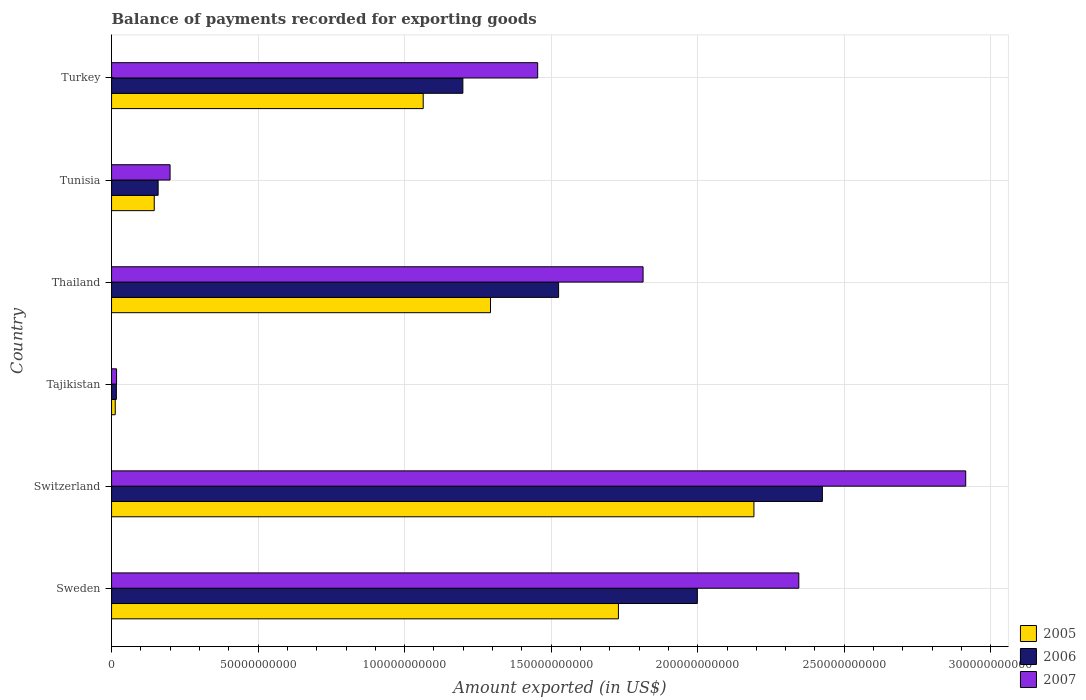How many different coloured bars are there?
Your response must be concise. 3. How many groups of bars are there?
Your answer should be compact. 6. Are the number of bars per tick equal to the number of legend labels?
Keep it short and to the point. Yes. What is the label of the 1st group of bars from the top?
Provide a succinct answer. Turkey. What is the amount exported in 2005 in Tajikistan?
Your response must be concise. 1.25e+09. Across all countries, what is the maximum amount exported in 2006?
Provide a short and direct response. 2.43e+11. Across all countries, what is the minimum amount exported in 2007?
Provide a succinct answer. 1.71e+09. In which country was the amount exported in 2005 maximum?
Your response must be concise. Switzerland. In which country was the amount exported in 2007 minimum?
Your answer should be very brief. Tajikistan. What is the total amount exported in 2007 in the graph?
Give a very brief answer. 8.74e+11. What is the difference between the amount exported in 2006 in Sweden and that in Tunisia?
Provide a short and direct response. 1.84e+11. What is the difference between the amount exported in 2006 in Tunisia and the amount exported in 2007 in Switzerland?
Provide a succinct answer. -2.76e+11. What is the average amount exported in 2005 per country?
Provide a succinct answer. 1.07e+11. What is the difference between the amount exported in 2005 and amount exported in 2006 in Turkey?
Provide a succinct answer. -1.35e+1. In how many countries, is the amount exported in 2005 greater than 210000000000 US$?
Ensure brevity in your answer.  1. What is the ratio of the amount exported in 2006 in Switzerland to that in Tajikistan?
Give a very brief answer. 147.34. Is the difference between the amount exported in 2005 in Tajikistan and Thailand greater than the difference between the amount exported in 2006 in Tajikistan and Thailand?
Give a very brief answer. Yes. What is the difference between the highest and the second highest amount exported in 2005?
Give a very brief answer. 4.62e+1. What is the difference between the highest and the lowest amount exported in 2007?
Keep it short and to the point. 2.90e+11. In how many countries, is the amount exported in 2006 greater than the average amount exported in 2006 taken over all countries?
Keep it short and to the point. 3. Is the sum of the amount exported in 2007 in Switzerland and Tajikistan greater than the maximum amount exported in 2006 across all countries?
Offer a terse response. Yes. What does the 1st bar from the top in Tunisia represents?
Make the answer very short. 2007. How many bars are there?
Your answer should be compact. 18. Are all the bars in the graph horizontal?
Ensure brevity in your answer.  Yes. How many countries are there in the graph?
Your response must be concise. 6. What is the difference between two consecutive major ticks on the X-axis?
Your answer should be very brief. 5.00e+1. What is the title of the graph?
Your response must be concise. Balance of payments recorded for exporting goods. What is the label or title of the X-axis?
Provide a succinct answer. Amount exported (in US$). What is the Amount exported (in US$) of 2005 in Sweden?
Your response must be concise. 1.73e+11. What is the Amount exported (in US$) in 2006 in Sweden?
Keep it short and to the point. 2.00e+11. What is the Amount exported (in US$) of 2007 in Sweden?
Give a very brief answer. 2.34e+11. What is the Amount exported (in US$) in 2005 in Switzerland?
Give a very brief answer. 2.19e+11. What is the Amount exported (in US$) of 2006 in Switzerland?
Provide a succinct answer. 2.43e+11. What is the Amount exported (in US$) in 2007 in Switzerland?
Give a very brief answer. 2.91e+11. What is the Amount exported (in US$) of 2005 in Tajikistan?
Offer a very short reply. 1.25e+09. What is the Amount exported (in US$) in 2006 in Tajikistan?
Give a very brief answer. 1.65e+09. What is the Amount exported (in US$) of 2007 in Tajikistan?
Offer a very short reply. 1.71e+09. What is the Amount exported (in US$) in 2005 in Thailand?
Your answer should be compact. 1.29e+11. What is the Amount exported (in US$) in 2006 in Thailand?
Give a very brief answer. 1.53e+11. What is the Amount exported (in US$) of 2007 in Thailand?
Provide a succinct answer. 1.81e+11. What is the Amount exported (in US$) in 2005 in Tunisia?
Make the answer very short. 1.46e+1. What is the Amount exported (in US$) of 2006 in Tunisia?
Keep it short and to the point. 1.59e+1. What is the Amount exported (in US$) of 2007 in Tunisia?
Ensure brevity in your answer.  2.00e+1. What is the Amount exported (in US$) of 2005 in Turkey?
Give a very brief answer. 1.06e+11. What is the Amount exported (in US$) of 2006 in Turkey?
Your answer should be very brief. 1.20e+11. What is the Amount exported (in US$) of 2007 in Turkey?
Keep it short and to the point. 1.45e+11. Across all countries, what is the maximum Amount exported (in US$) in 2005?
Your answer should be very brief. 2.19e+11. Across all countries, what is the maximum Amount exported (in US$) of 2006?
Make the answer very short. 2.43e+11. Across all countries, what is the maximum Amount exported (in US$) in 2007?
Your response must be concise. 2.91e+11. Across all countries, what is the minimum Amount exported (in US$) of 2005?
Your answer should be compact. 1.25e+09. Across all countries, what is the minimum Amount exported (in US$) of 2006?
Your response must be concise. 1.65e+09. Across all countries, what is the minimum Amount exported (in US$) of 2007?
Keep it short and to the point. 1.71e+09. What is the total Amount exported (in US$) in 2005 in the graph?
Your answer should be compact. 6.44e+11. What is the total Amount exported (in US$) of 2006 in the graph?
Your answer should be compact. 7.32e+11. What is the total Amount exported (in US$) in 2007 in the graph?
Your response must be concise. 8.74e+11. What is the difference between the Amount exported (in US$) in 2005 in Sweden and that in Switzerland?
Your response must be concise. -4.62e+1. What is the difference between the Amount exported (in US$) of 2006 in Sweden and that in Switzerland?
Make the answer very short. -4.27e+1. What is the difference between the Amount exported (in US$) in 2007 in Sweden and that in Switzerland?
Your answer should be very brief. -5.69e+1. What is the difference between the Amount exported (in US$) of 2005 in Sweden and that in Tajikistan?
Provide a short and direct response. 1.72e+11. What is the difference between the Amount exported (in US$) of 2006 in Sweden and that in Tajikistan?
Your response must be concise. 1.98e+11. What is the difference between the Amount exported (in US$) in 2007 in Sweden and that in Tajikistan?
Provide a short and direct response. 2.33e+11. What is the difference between the Amount exported (in US$) in 2005 in Sweden and that in Thailand?
Provide a short and direct response. 4.36e+1. What is the difference between the Amount exported (in US$) of 2006 in Sweden and that in Thailand?
Your answer should be compact. 4.73e+1. What is the difference between the Amount exported (in US$) in 2007 in Sweden and that in Thailand?
Offer a terse response. 5.31e+1. What is the difference between the Amount exported (in US$) of 2005 in Sweden and that in Tunisia?
Give a very brief answer. 1.58e+11. What is the difference between the Amount exported (in US$) in 2006 in Sweden and that in Tunisia?
Give a very brief answer. 1.84e+11. What is the difference between the Amount exported (in US$) in 2007 in Sweden and that in Tunisia?
Offer a terse response. 2.15e+11. What is the difference between the Amount exported (in US$) in 2005 in Sweden and that in Turkey?
Provide a succinct answer. 6.66e+1. What is the difference between the Amount exported (in US$) in 2006 in Sweden and that in Turkey?
Ensure brevity in your answer.  8.00e+1. What is the difference between the Amount exported (in US$) in 2007 in Sweden and that in Turkey?
Offer a terse response. 8.91e+1. What is the difference between the Amount exported (in US$) of 2005 in Switzerland and that in Tajikistan?
Ensure brevity in your answer.  2.18e+11. What is the difference between the Amount exported (in US$) of 2006 in Switzerland and that in Tajikistan?
Your answer should be very brief. 2.41e+11. What is the difference between the Amount exported (in US$) in 2007 in Switzerland and that in Tajikistan?
Provide a succinct answer. 2.90e+11. What is the difference between the Amount exported (in US$) in 2005 in Switzerland and that in Thailand?
Offer a very short reply. 8.99e+1. What is the difference between the Amount exported (in US$) of 2006 in Switzerland and that in Thailand?
Your answer should be compact. 9.00e+1. What is the difference between the Amount exported (in US$) in 2007 in Switzerland and that in Thailand?
Your answer should be very brief. 1.10e+11. What is the difference between the Amount exported (in US$) in 2005 in Switzerland and that in Tunisia?
Your answer should be compact. 2.05e+11. What is the difference between the Amount exported (in US$) of 2006 in Switzerland and that in Tunisia?
Your answer should be very brief. 2.27e+11. What is the difference between the Amount exported (in US$) of 2007 in Switzerland and that in Tunisia?
Your answer should be compact. 2.71e+11. What is the difference between the Amount exported (in US$) of 2005 in Switzerland and that in Turkey?
Give a very brief answer. 1.13e+11. What is the difference between the Amount exported (in US$) in 2006 in Switzerland and that in Turkey?
Give a very brief answer. 1.23e+11. What is the difference between the Amount exported (in US$) of 2007 in Switzerland and that in Turkey?
Give a very brief answer. 1.46e+11. What is the difference between the Amount exported (in US$) in 2005 in Tajikistan and that in Thailand?
Your answer should be compact. -1.28e+11. What is the difference between the Amount exported (in US$) in 2006 in Tajikistan and that in Thailand?
Offer a very short reply. -1.51e+11. What is the difference between the Amount exported (in US$) in 2007 in Tajikistan and that in Thailand?
Your response must be concise. -1.80e+11. What is the difference between the Amount exported (in US$) in 2005 in Tajikistan and that in Tunisia?
Your answer should be very brief. -1.33e+1. What is the difference between the Amount exported (in US$) in 2006 in Tajikistan and that in Tunisia?
Give a very brief answer. -1.42e+1. What is the difference between the Amount exported (in US$) in 2007 in Tajikistan and that in Tunisia?
Your answer should be very brief. -1.83e+1. What is the difference between the Amount exported (in US$) of 2005 in Tajikistan and that in Turkey?
Give a very brief answer. -1.05e+11. What is the difference between the Amount exported (in US$) of 2006 in Tajikistan and that in Turkey?
Provide a short and direct response. -1.18e+11. What is the difference between the Amount exported (in US$) in 2007 in Tajikistan and that in Turkey?
Offer a very short reply. -1.44e+11. What is the difference between the Amount exported (in US$) in 2005 in Thailand and that in Tunisia?
Your answer should be very brief. 1.15e+11. What is the difference between the Amount exported (in US$) in 2006 in Thailand and that in Tunisia?
Keep it short and to the point. 1.37e+11. What is the difference between the Amount exported (in US$) of 2007 in Thailand and that in Tunisia?
Make the answer very short. 1.61e+11. What is the difference between the Amount exported (in US$) in 2005 in Thailand and that in Turkey?
Your response must be concise. 2.30e+1. What is the difference between the Amount exported (in US$) in 2006 in Thailand and that in Turkey?
Provide a short and direct response. 3.27e+1. What is the difference between the Amount exported (in US$) in 2007 in Thailand and that in Turkey?
Your answer should be compact. 3.60e+1. What is the difference between the Amount exported (in US$) in 2005 in Tunisia and that in Turkey?
Your answer should be compact. -9.18e+1. What is the difference between the Amount exported (in US$) in 2006 in Tunisia and that in Turkey?
Your answer should be compact. -1.04e+11. What is the difference between the Amount exported (in US$) in 2007 in Tunisia and that in Turkey?
Ensure brevity in your answer.  -1.25e+11. What is the difference between the Amount exported (in US$) in 2005 in Sweden and the Amount exported (in US$) in 2006 in Switzerland?
Your answer should be compact. -6.96e+1. What is the difference between the Amount exported (in US$) of 2005 in Sweden and the Amount exported (in US$) of 2007 in Switzerland?
Provide a short and direct response. -1.18e+11. What is the difference between the Amount exported (in US$) in 2006 in Sweden and the Amount exported (in US$) in 2007 in Switzerland?
Offer a terse response. -9.16e+1. What is the difference between the Amount exported (in US$) of 2005 in Sweden and the Amount exported (in US$) of 2006 in Tajikistan?
Provide a succinct answer. 1.71e+11. What is the difference between the Amount exported (in US$) of 2005 in Sweden and the Amount exported (in US$) of 2007 in Tajikistan?
Your answer should be compact. 1.71e+11. What is the difference between the Amount exported (in US$) of 2006 in Sweden and the Amount exported (in US$) of 2007 in Tajikistan?
Keep it short and to the point. 1.98e+11. What is the difference between the Amount exported (in US$) in 2005 in Sweden and the Amount exported (in US$) in 2006 in Thailand?
Ensure brevity in your answer.  2.04e+1. What is the difference between the Amount exported (in US$) of 2005 in Sweden and the Amount exported (in US$) of 2007 in Thailand?
Provide a short and direct response. -8.41e+09. What is the difference between the Amount exported (in US$) of 2006 in Sweden and the Amount exported (in US$) of 2007 in Thailand?
Your response must be concise. 1.85e+1. What is the difference between the Amount exported (in US$) of 2005 in Sweden and the Amount exported (in US$) of 2006 in Tunisia?
Offer a very short reply. 1.57e+11. What is the difference between the Amount exported (in US$) of 2005 in Sweden and the Amount exported (in US$) of 2007 in Tunisia?
Offer a very short reply. 1.53e+11. What is the difference between the Amount exported (in US$) in 2006 in Sweden and the Amount exported (in US$) in 2007 in Tunisia?
Offer a terse response. 1.80e+11. What is the difference between the Amount exported (in US$) of 2005 in Sweden and the Amount exported (in US$) of 2006 in Turkey?
Give a very brief answer. 5.31e+1. What is the difference between the Amount exported (in US$) of 2005 in Sweden and the Amount exported (in US$) of 2007 in Turkey?
Make the answer very short. 2.76e+1. What is the difference between the Amount exported (in US$) in 2006 in Sweden and the Amount exported (in US$) in 2007 in Turkey?
Offer a terse response. 5.45e+1. What is the difference between the Amount exported (in US$) of 2005 in Switzerland and the Amount exported (in US$) of 2006 in Tajikistan?
Keep it short and to the point. 2.18e+11. What is the difference between the Amount exported (in US$) of 2005 in Switzerland and the Amount exported (in US$) of 2007 in Tajikistan?
Make the answer very short. 2.17e+11. What is the difference between the Amount exported (in US$) of 2006 in Switzerland and the Amount exported (in US$) of 2007 in Tajikistan?
Offer a very short reply. 2.41e+11. What is the difference between the Amount exported (in US$) in 2005 in Switzerland and the Amount exported (in US$) in 2006 in Thailand?
Provide a short and direct response. 6.66e+1. What is the difference between the Amount exported (in US$) in 2005 in Switzerland and the Amount exported (in US$) in 2007 in Thailand?
Ensure brevity in your answer.  3.78e+1. What is the difference between the Amount exported (in US$) in 2006 in Switzerland and the Amount exported (in US$) in 2007 in Thailand?
Make the answer very short. 6.12e+1. What is the difference between the Amount exported (in US$) of 2005 in Switzerland and the Amount exported (in US$) of 2006 in Tunisia?
Make the answer very short. 2.03e+11. What is the difference between the Amount exported (in US$) in 2005 in Switzerland and the Amount exported (in US$) in 2007 in Tunisia?
Ensure brevity in your answer.  1.99e+11. What is the difference between the Amount exported (in US$) in 2006 in Switzerland and the Amount exported (in US$) in 2007 in Tunisia?
Offer a terse response. 2.23e+11. What is the difference between the Amount exported (in US$) in 2005 in Switzerland and the Amount exported (in US$) in 2006 in Turkey?
Make the answer very short. 9.93e+1. What is the difference between the Amount exported (in US$) in 2005 in Switzerland and the Amount exported (in US$) in 2007 in Turkey?
Provide a succinct answer. 7.38e+1. What is the difference between the Amount exported (in US$) of 2006 in Switzerland and the Amount exported (in US$) of 2007 in Turkey?
Make the answer very short. 9.71e+1. What is the difference between the Amount exported (in US$) of 2005 in Tajikistan and the Amount exported (in US$) of 2006 in Thailand?
Give a very brief answer. -1.51e+11. What is the difference between the Amount exported (in US$) in 2005 in Tajikistan and the Amount exported (in US$) in 2007 in Thailand?
Provide a succinct answer. -1.80e+11. What is the difference between the Amount exported (in US$) in 2006 in Tajikistan and the Amount exported (in US$) in 2007 in Thailand?
Provide a short and direct response. -1.80e+11. What is the difference between the Amount exported (in US$) of 2005 in Tajikistan and the Amount exported (in US$) of 2006 in Tunisia?
Provide a succinct answer. -1.46e+1. What is the difference between the Amount exported (in US$) in 2005 in Tajikistan and the Amount exported (in US$) in 2007 in Tunisia?
Keep it short and to the point. -1.87e+1. What is the difference between the Amount exported (in US$) in 2006 in Tajikistan and the Amount exported (in US$) in 2007 in Tunisia?
Offer a very short reply. -1.83e+1. What is the difference between the Amount exported (in US$) in 2005 in Tajikistan and the Amount exported (in US$) in 2006 in Turkey?
Your response must be concise. -1.19e+11. What is the difference between the Amount exported (in US$) in 2005 in Tajikistan and the Amount exported (in US$) in 2007 in Turkey?
Your answer should be compact. -1.44e+11. What is the difference between the Amount exported (in US$) in 2006 in Tajikistan and the Amount exported (in US$) in 2007 in Turkey?
Your answer should be very brief. -1.44e+11. What is the difference between the Amount exported (in US$) of 2005 in Thailand and the Amount exported (in US$) of 2006 in Tunisia?
Offer a terse response. 1.13e+11. What is the difference between the Amount exported (in US$) of 2005 in Thailand and the Amount exported (in US$) of 2007 in Tunisia?
Your answer should be compact. 1.09e+11. What is the difference between the Amount exported (in US$) of 2006 in Thailand and the Amount exported (in US$) of 2007 in Tunisia?
Ensure brevity in your answer.  1.33e+11. What is the difference between the Amount exported (in US$) of 2005 in Thailand and the Amount exported (in US$) of 2006 in Turkey?
Ensure brevity in your answer.  9.43e+09. What is the difference between the Amount exported (in US$) of 2005 in Thailand and the Amount exported (in US$) of 2007 in Turkey?
Ensure brevity in your answer.  -1.61e+1. What is the difference between the Amount exported (in US$) of 2006 in Thailand and the Amount exported (in US$) of 2007 in Turkey?
Ensure brevity in your answer.  7.15e+09. What is the difference between the Amount exported (in US$) in 2005 in Tunisia and the Amount exported (in US$) in 2006 in Turkey?
Ensure brevity in your answer.  -1.05e+11. What is the difference between the Amount exported (in US$) in 2005 in Tunisia and the Amount exported (in US$) in 2007 in Turkey?
Keep it short and to the point. -1.31e+11. What is the difference between the Amount exported (in US$) of 2006 in Tunisia and the Amount exported (in US$) of 2007 in Turkey?
Provide a short and direct response. -1.29e+11. What is the average Amount exported (in US$) of 2005 per country?
Ensure brevity in your answer.  1.07e+11. What is the average Amount exported (in US$) in 2006 per country?
Your answer should be very brief. 1.22e+11. What is the average Amount exported (in US$) of 2007 per country?
Your answer should be compact. 1.46e+11. What is the difference between the Amount exported (in US$) in 2005 and Amount exported (in US$) in 2006 in Sweden?
Ensure brevity in your answer.  -2.69e+1. What is the difference between the Amount exported (in US$) of 2005 and Amount exported (in US$) of 2007 in Sweden?
Keep it short and to the point. -6.15e+1. What is the difference between the Amount exported (in US$) of 2006 and Amount exported (in US$) of 2007 in Sweden?
Give a very brief answer. -3.46e+1. What is the difference between the Amount exported (in US$) of 2005 and Amount exported (in US$) of 2006 in Switzerland?
Your answer should be compact. -2.34e+1. What is the difference between the Amount exported (in US$) in 2005 and Amount exported (in US$) in 2007 in Switzerland?
Give a very brief answer. -7.23e+1. What is the difference between the Amount exported (in US$) of 2006 and Amount exported (in US$) of 2007 in Switzerland?
Offer a very short reply. -4.89e+1. What is the difference between the Amount exported (in US$) of 2005 and Amount exported (in US$) of 2006 in Tajikistan?
Your answer should be very brief. -3.92e+08. What is the difference between the Amount exported (in US$) in 2005 and Amount exported (in US$) in 2007 in Tajikistan?
Ensure brevity in your answer.  -4.51e+08. What is the difference between the Amount exported (in US$) of 2006 and Amount exported (in US$) of 2007 in Tajikistan?
Provide a succinct answer. -5.96e+07. What is the difference between the Amount exported (in US$) of 2005 and Amount exported (in US$) of 2006 in Thailand?
Give a very brief answer. -2.32e+1. What is the difference between the Amount exported (in US$) of 2005 and Amount exported (in US$) of 2007 in Thailand?
Your answer should be very brief. -5.21e+1. What is the difference between the Amount exported (in US$) of 2006 and Amount exported (in US$) of 2007 in Thailand?
Your answer should be compact. -2.88e+1. What is the difference between the Amount exported (in US$) in 2005 and Amount exported (in US$) in 2006 in Tunisia?
Your answer should be compact. -1.32e+09. What is the difference between the Amount exported (in US$) of 2005 and Amount exported (in US$) of 2007 in Tunisia?
Your response must be concise. -5.40e+09. What is the difference between the Amount exported (in US$) of 2006 and Amount exported (in US$) of 2007 in Tunisia?
Make the answer very short. -4.07e+09. What is the difference between the Amount exported (in US$) of 2005 and Amount exported (in US$) of 2006 in Turkey?
Keep it short and to the point. -1.35e+1. What is the difference between the Amount exported (in US$) in 2005 and Amount exported (in US$) in 2007 in Turkey?
Offer a very short reply. -3.91e+1. What is the difference between the Amount exported (in US$) in 2006 and Amount exported (in US$) in 2007 in Turkey?
Make the answer very short. -2.55e+1. What is the ratio of the Amount exported (in US$) of 2005 in Sweden to that in Switzerland?
Your answer should be very brief. 0.79. What is the ratio of the Amount exported (in US$) of 2006 in Sweden to that in Switzerland?
Provide a succinct answer. 0.82. What is the ratio of the Amount exported (in US$) in 2007 in Sweden to that in Switzerland?
Make the answer very short. 0.8. What is the ratio of the Amount exported (in US$) in 2005 in Sweden to that in Tajikistan?
Your response must be concise. 137.86. What is the ratio of the Amount exported (in US$) in 2006 in Sweden to that in Tajikistan?
Ensure brevity in your answer.  121.42. What is the ratio of the Amount exported (in US$) of 2007 in Sweden to that in Tajikistan?
Your response must be concise. 137.48. What is the ratio of the Amount exported (in US$) in 2005 in Sweden to that in Thailand?
Give a very brief answer. 1.34. What is the ratio of the Amount exported (in US$) of 2006 in Sweden to that in Thailand?
Keep it short and to the point. 1.31. What is the ratio of the Amount exported (in US$) in 2007 in Sweden to that in Thailand?
Your response must be concise. 1.29. What is the ratio of the Amount exported (in US$) of 2005 in Sweden to that in Tunisia?
Your answer should be very brief. 11.87. What is the ratio of the Amount exported (in US$) in 2006 in Sweden to that in Tunisia?
Provide a succinct answer. 12.58. What is the ratio of the Amount exported (in US$) of 2007 in Sweden to that in Tunisia?
Ensure brevity in your answer.  11.75. What is the ratio of the Amount exported (in US$) in 2005 in Sweden to that in Turkey?
Provide a succinct answer. 1.63. What is the ratio of the Amount exported (in US$) in 2006 in Sweden to that in Turkey?
Keep it short and to the point. 1.67. What is the ratio of the Amount exported (in US$) in 2007 in Sweden to that in Turkey?
Offer a very short reply. 1.61. What is the ratio of the Amount exported (in US$) in 2005 in Switzerland to that in Tajikistan?
Offer a very short reply. 174.72. What is the ratio of the Amount exported (in US$) of 2006 in Switzerland to that in Tajikistan?
Your answer should be very brief. 147.34. What is the ratio of the Amount exported (in US$) of 2007 in Switzerland to that in Tajikistan?
Keep it short and to the point. 170.87. What is the ratio of the Amount exported (in US$) in 2005 in Switzerland to that in Thailand?
Your answer should be compact. 1.7. What is the ratio of the Amount exported (in US$) in 2006 in Switzerland to that in Thailand?
Your answer should be compact. 1.59. What is the ratio of the Amount exported (in US$) in 2007 in Switzerland to that in Thailand?
Your answer should be very brief. 1.61. What is the ratio of the Amount exported (in US$) in 2005 in Switzerland to that in Tunisia?
Ensure brevity in your answer.  15.04. What is the ratio of the Amount exported (in US$) in 2006 in Switzerland to that in Tunisia?
Your response must be concise. 15.26. What is the ratio of the Amount exported (in US$) of 2007 in Switzerland to that in Tunisia?
Give a very brief answer. 14.6. What is the ratio of the Amount exported (in US$) of 2005 in Switzerland to that in Turkey?
Your answer should be very brief. 2.06. What is the ratio of the Amount exported (in US$) in 2006 in Switzerland to that in Turkey?
Keep it short and to the point. 2.02. What is the ratio of the Amount exported (in US$) of 2007 in Switzerland to that in Turkey?
Your answer should be compact. 2. What is the ratio of the Amount exported (in US$) of 2005 in Tajikistan to that in Thailand?
Provide a succinct answer. 0.01. What is the ratio of the Amount exported (in US$) of 2006 in Tajikistan to that in Thailand?
Give a very brief answer. 0.01. What is the ratio of the Amount exported (in US$) of 2007 in Tajikistan to that in Thailand?
Keep it short and to the point. 0.01. What is the ratio of the Amount exported (in US$) in 2005 in Tajikistan to that in Tunisia?
Your response must be concise. 0.09. What is the ratio of the Amount exported (in US$) in 2006 in Tajikistan to that in Tunisia?
Provide a succinct answer. 0.1. What is the ratio of the Amount exported (in US$) in 2007 in Tajikistan to that in Tunisia?
Make the answer very short. 0.09. What is the ratio of the Amount exported (in US$) of 2005 in Tajikistan to that in Turkey?
Make the answer very short. 0.01. What is the ratio of the Amount exported (in US$) in 2006 in Tajikistan to that in Turkey?
Offer a very short reply. 0.01. What is the ratio of the Amount exported (in US$) of 2007 in Tajikistan to that in Turkey?
Give a very brief answer. 0.01. What is the ratio of the Amount exported (in US$) of 2005 in Thailand to that in Tunisia?
Provide a succinct answer. 8.88. What is the ratio of the Amount exported (in US$) of 2006 in Thailand to that in Tunisia?
Provide a short and direct response. 9.6. What is the ratio of the Amount exported (in US$) in 2007 in Thailand to that in Tunisia?
Provide a succinct answer. 9.08. What is the ratio of the Amount exported (in US$) in 2005 in Thailand to that in Turkey?
Your response must be concise. 1.22. What is the ratio of the Amount exported (in US$) in 2006 in Thailand to that in Turkey?
Offer a terse response. 1.27. What is the ratio of the Amount exported (in US$) of 2007 in Thailand to that in Turkey?
Give a very brief answer. 1.25. What is the ratio of the Amount exported (in US$) of 2005 in Tunisia to that in Turkey?
Offer a very short reply. 0.14. What is the ratio of the Amount exported (in US$) in 2006 in Tunisia to that in Turkey?
Provide a succinct answer. 0.13. What is the ratio of the Amount exported (in US$) of 2007 in Tunisia to that in Turkey?
Your answer should be very brief. 0.14. What is the difference between the highest and the second highest Amount exported (in US$) of 2005?
Your response must be concise. 4.62e+1. What is the difference between the highest and the second highest Amount exported (in US$) in 2006?
Keep it short and to the point. 4.27e+1. What is the difference between the highest and the second highest Amount exported (in US$) of 2007?
Offer a terse response. 5.69e+1. What is the difference between the highest and the lowest Amount exported (in US$) of 2005?
Offer a very short reply. 2.18e+11. What is the difference between the highest and the lowest Amount exported (in US$) in 2006?
Offer a terse response. 2.41e+11. What is the difference between the highest and the lowest Amount exported (in US$) in 2007?
Offer a very short reply. 2.90e+11. 